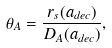Convert formula to latex. <formula><loc_0><loc_0><loc_500><loc_500>\theta _ { A } = \frac { r _ { s } ( a _ { d e c } ) } { D _ { A } ( a _ { d e c } ) } ,</formula> 